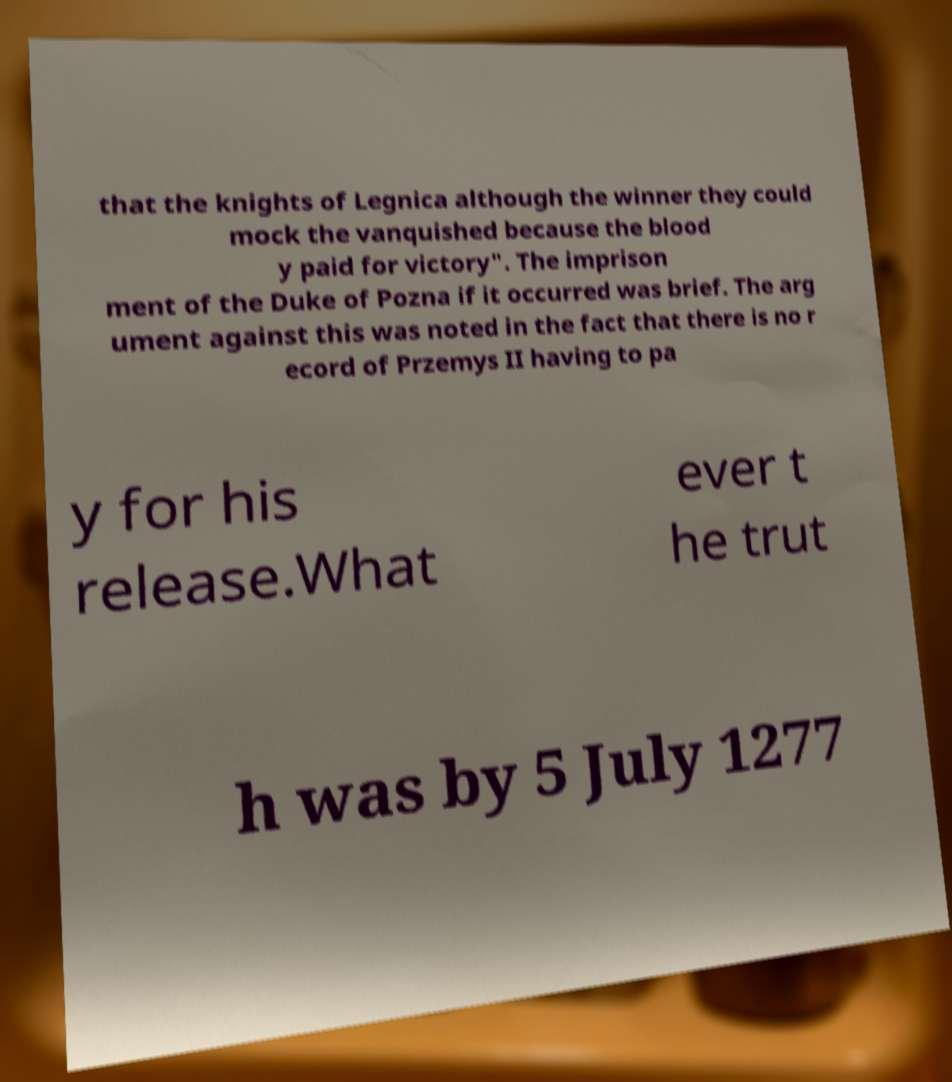I need the written content from this picture converted into text. Can you do that? that the knights of Legnica although the winner they could mock the vanquished because the blood y paid for victory". The imprison ment of the Duke of Pozna if it occurred was brief. The arg ument against this was noted in the fact that there is no r ecord of Przemys II having to pa y for his release.What ever t he trut h was by 5 July 1277 